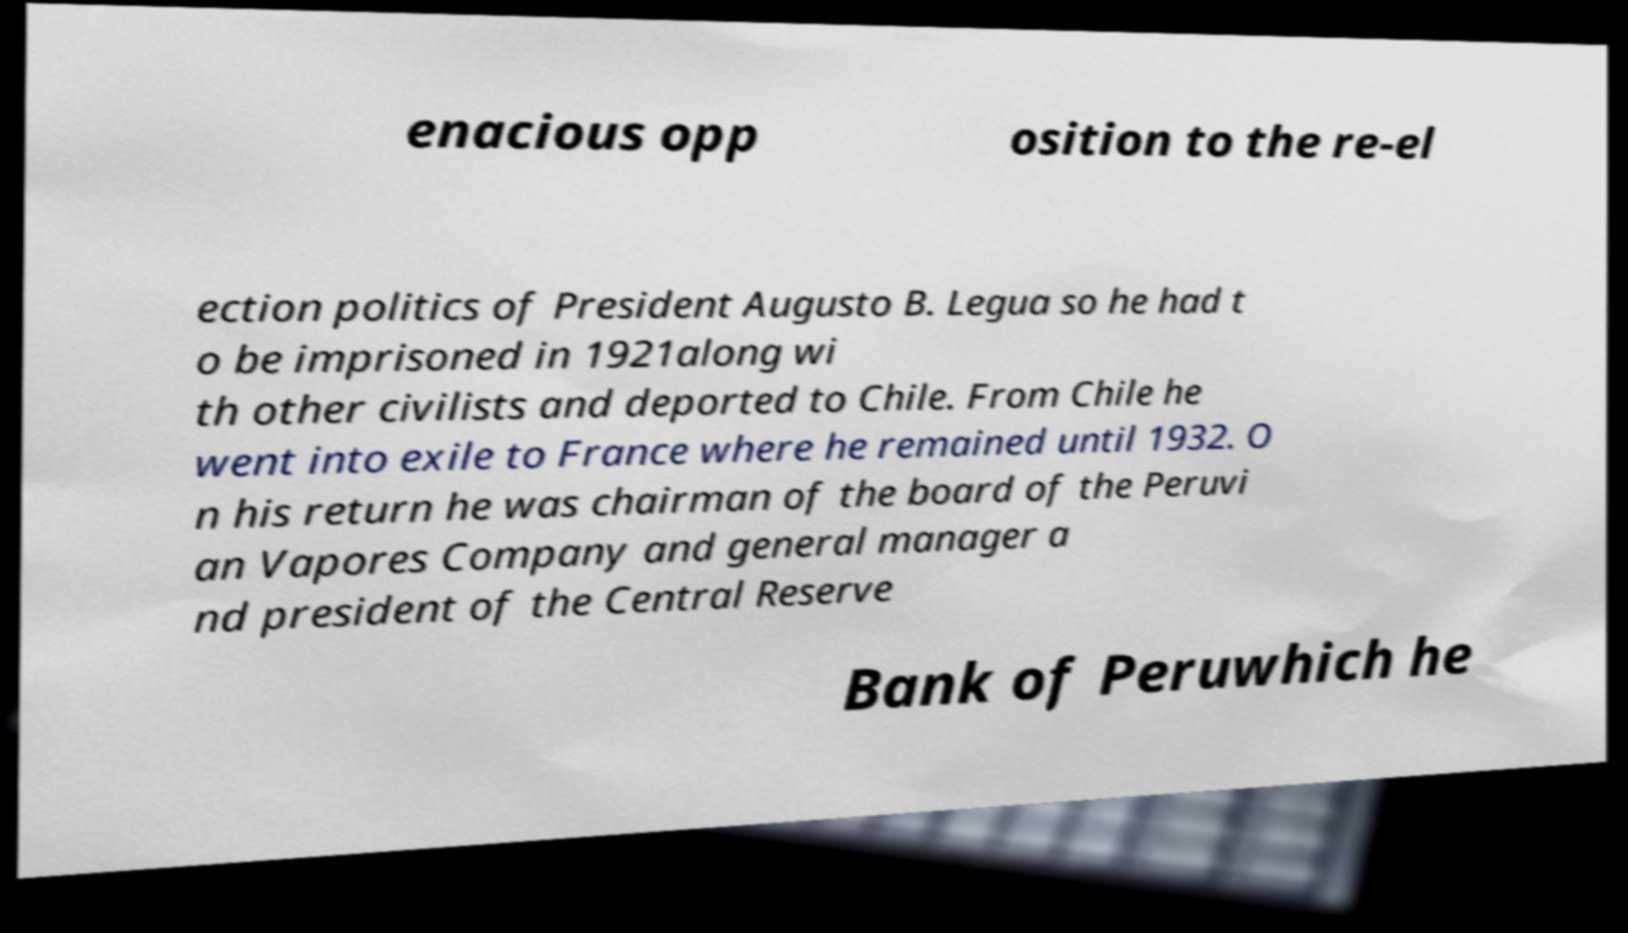Can you accurately transcribe the text from the provided image for me? enacious opp osition to the re-el ection politics of President Augusto B. Legua so he had t o be imprisoned in 1921along wi th other civilists and deported to Chile. From Chile he went into exile to France where he remained until 1932. O n his return he was chairman of the board of the Peruvi an Vapores Company and general manager a nd president of the Central Reserve Bank of Peruwhich he 